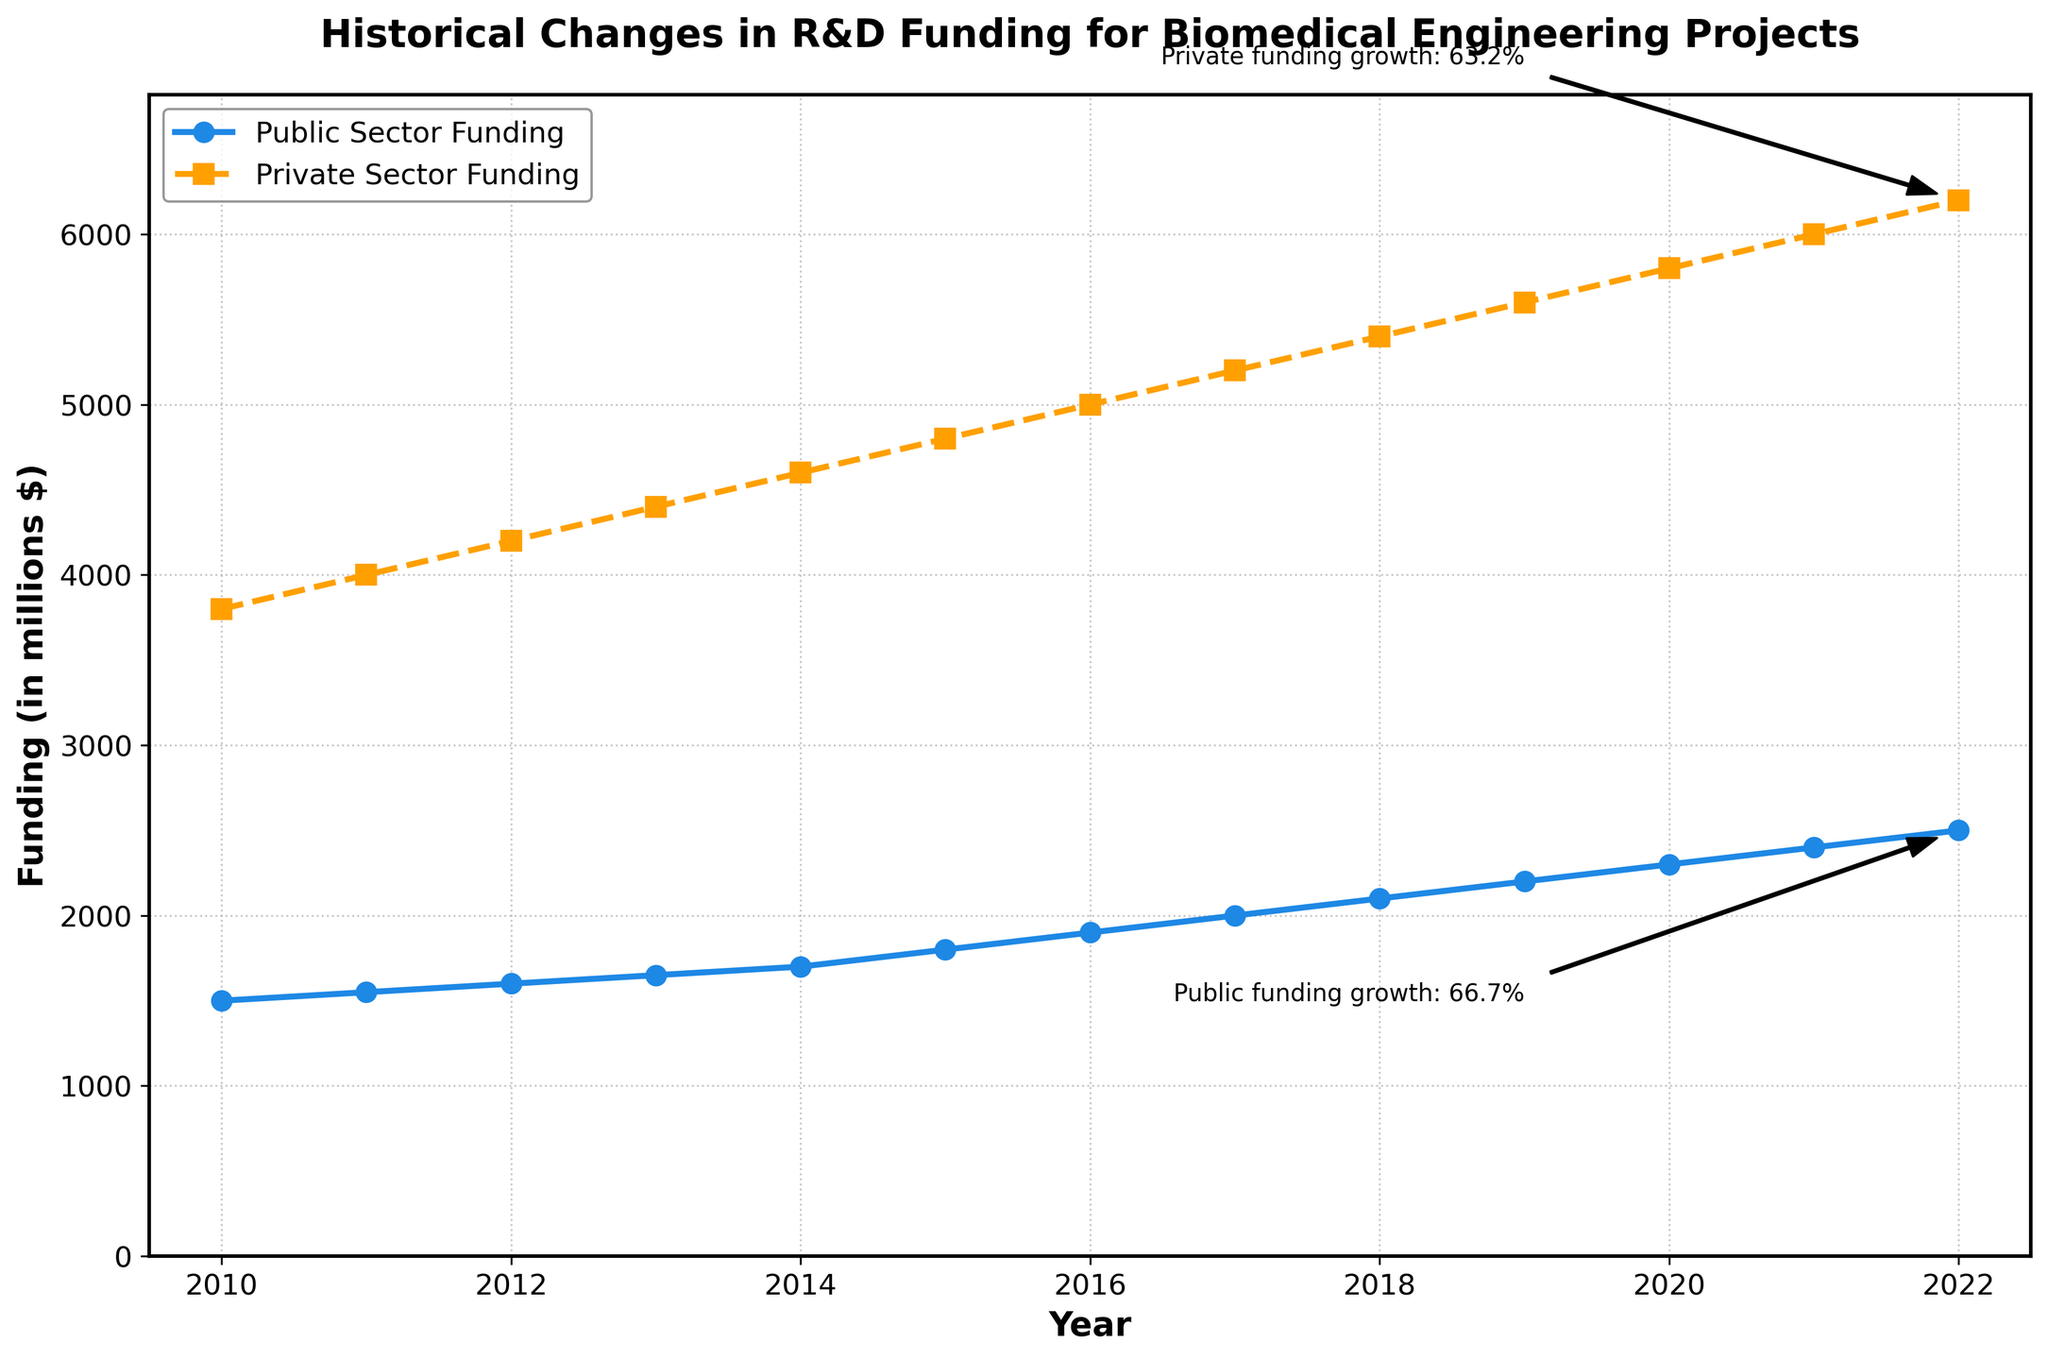What's the title of the figure? The title is located at the top of the figure and is in bold text. It summarizes the content of the figure.
Answer: Historical Changes in R&D Funding for Biomedical Engineering Projects How does the funding in the public sector change from 2010 to 2022? Observing the blue line that represents public sector funding, it starts at $1500 million in 2010 and increases to $2500 million in 2022, indicating growth.
Answer: It increases What was the private sector funding in 2016? The orange dashed line representing private sector funding intersects the vertical line of 2016 at approximately $5000 million.
Answer: $5000 million Which sector had higher funding in 2013 and by how much? In 2013, comparing the blue line for public sector funding and the orange dashed line for private sector funding, private sector funding was at $4400 million, while public sector funding was at $1650 million. Subtracting these gives the difference.
Answer: Private sector by $2750 million What's the average public sector funding from 2010 to 2022? Sum all public sector funding values from 2010 to 2022 and divide by the number of years (13). Sum = $31500 million, and \(average = \frac{31500}{13}\).
Answer: $2423.08 million In which year did both public and private sector funding cross $2000 million and $5000 million respectively? Identifying the years where the blue line for public sector funding crosses $2000 million and where the orange dashed line for private sector funding crosses $5000 million. For public, it’s 2017, and for private, it’s 2016.
Answer: 2017 and 2016 How much did private sector funding grow from 2010 to 2022 in percentage? The initial funding in 2010 was $3800 million and the final amount in 2022 is $6200 million. The growth formula is \(\left(\frac{final - initial}{initial}\right) \times 100\%\): \(\left(\frac{6200 - 3800}{3800}\right) \times 100\% = 63.2\%\).
Answer: 63.2% What's the difference in public sector funding between 2015 and 2020? Subtract the public sector funding value for 2015 ($1800 million) from that of 2020 ($2300 million): \(2300 - 1800 = 500\).
Answer: $500 million What is the trend in private sector funding from 2010 to 2022? Observing the orange dashed line from 2010 to 2022 shows a steady increasing trend in private sector funding, starting from $3800 million in 2010 to $6200 million in 2022.
Answer: Increasing Which sector shows more fluctuation in their funding trends? Comparing the two lines, the public sector (blue line) and private sector (orange dashed line), neither shows significant fluctuations, both demonstrate steady growth. Therefore, neither can be said to fluctuate more.
Answer: Neither 